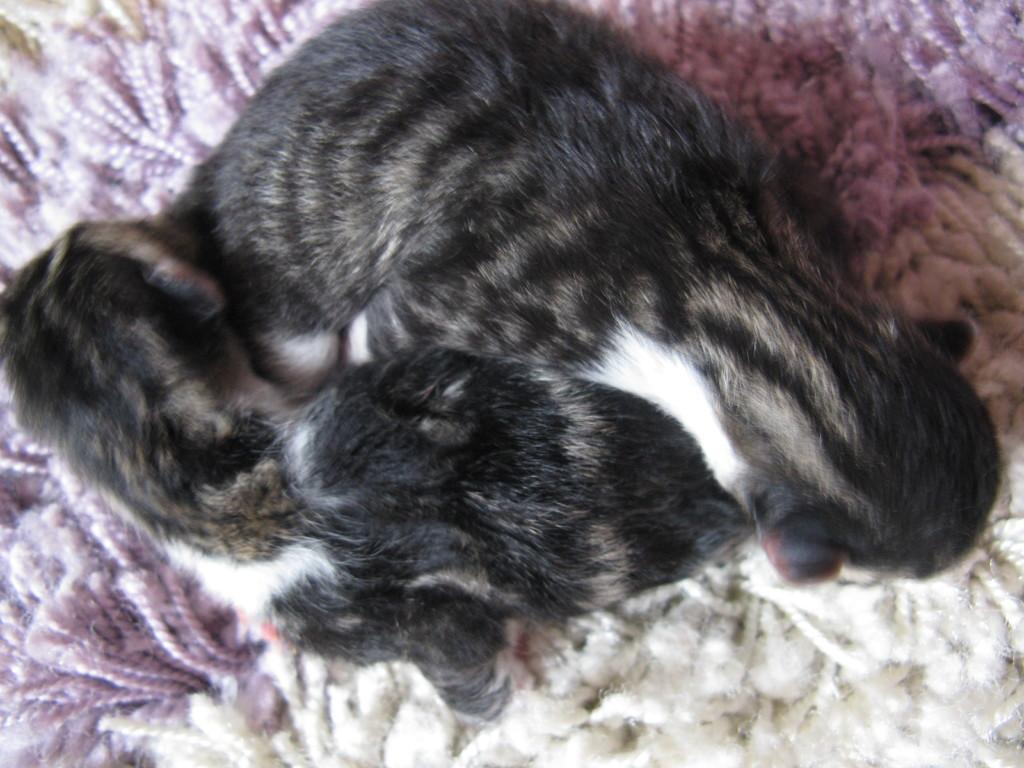How many cats are in the image? There are two cats in the image. What type of surface are the cats on? The cats are on a woolen surface. Where is the woolen surface located in the image? The woolen surface is in the foreground of the image. What type of organization is depicted in the image? There is no organization depicted in the image; it features two cats on a woolen surface. Is the image framed or unframed? The image itself does not have a frame, as the frame is not a part of the image. 